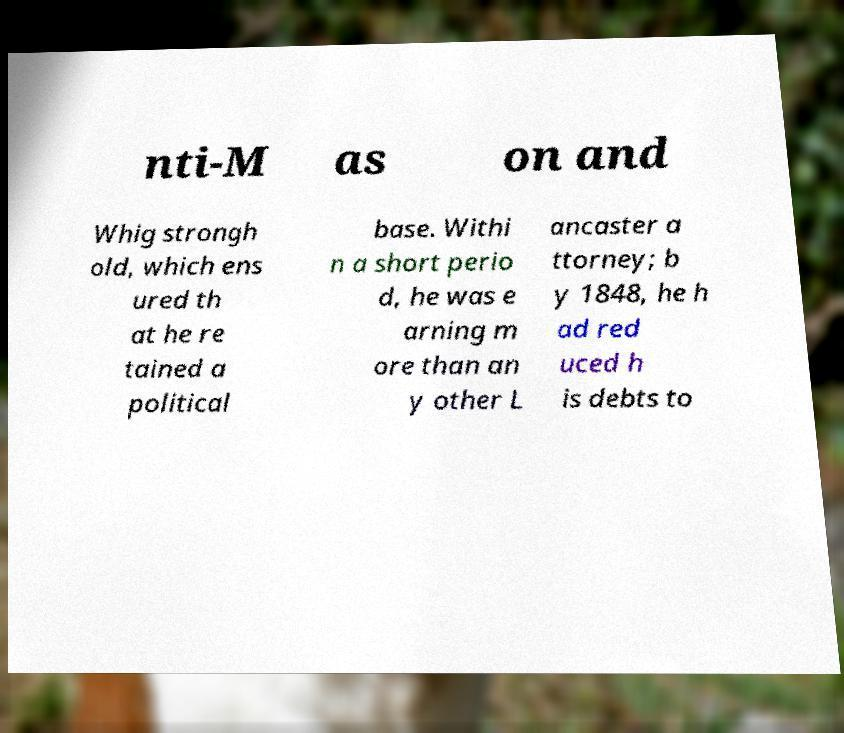What messages or text are displayed in this image? I need them in a readable, typed format. nti-M as on and Whig strongh old, which ens ured th at he re tained a political base. Withi n a short perio d, he was e arning m ore than an y other L ancaster a ttorney; b y 1848, he h ad red uced h is debts to 